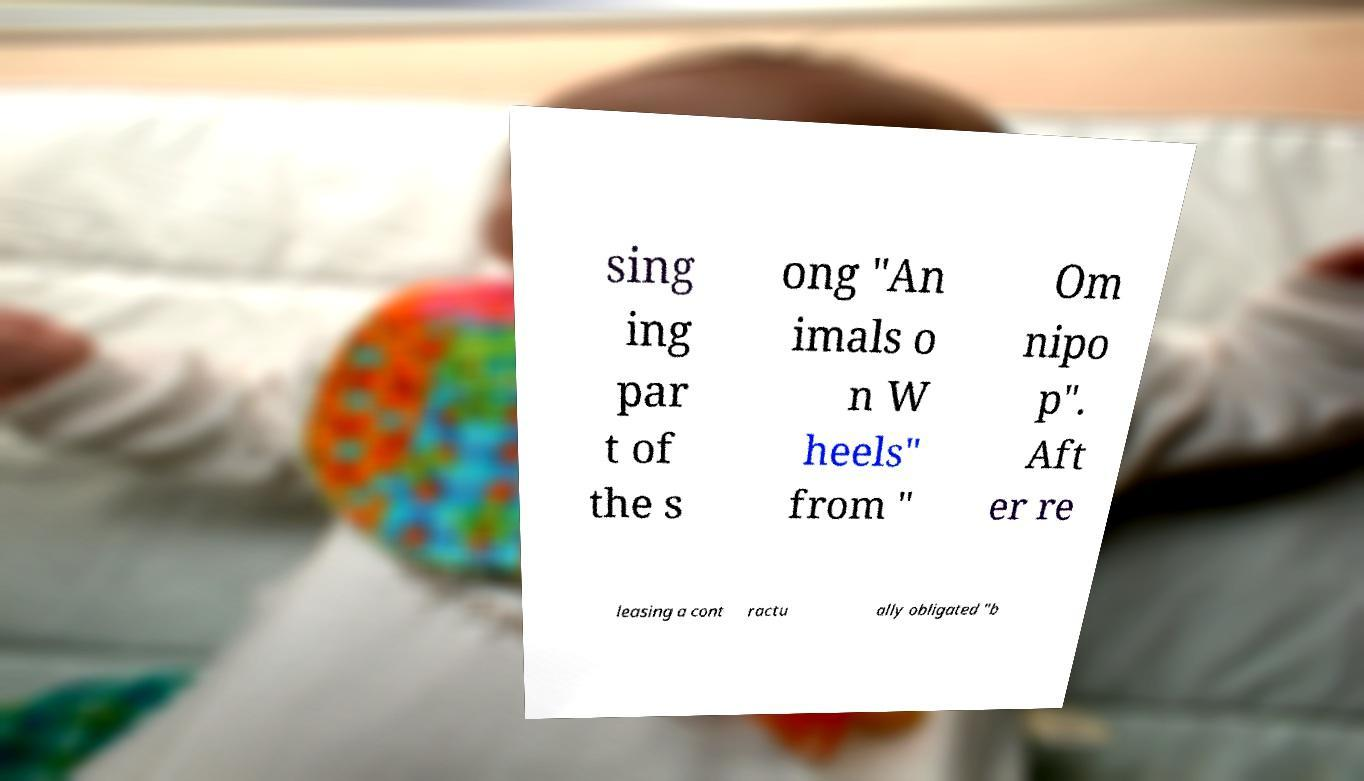Could you extract and type out the text from this image? sing ing par t of the s ong "An imals o n W heels" from " Om nipo p". Aft er re leasing a cont ractu ally obligated "b 